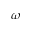<formula> <loc_0><loc_0><loc_500><loc_500>\omega</formula> 